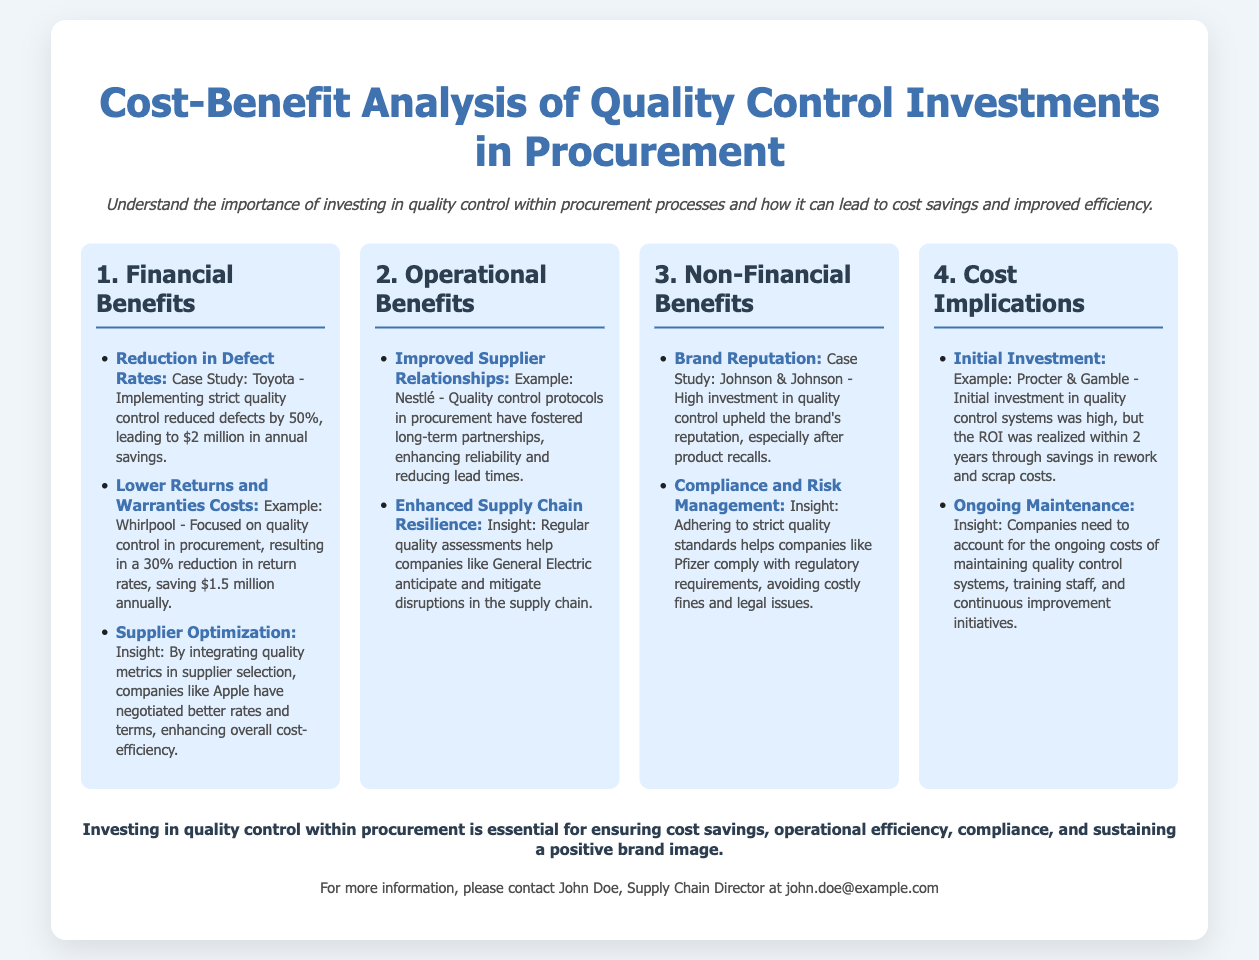what is the title of the presentation? The title of the presentation is prominently displayed at the top of the slide, which outlines the main subject matter.
Answer: Cost-Benefit Analysis of Quality Control Investments in Procurement how much did Toyota save annually after quality control implementation? The document provides a case study which mentions specific financial benefits from Toyota's quality control measures.
Answer: $2 million what percentage reduction in return rates did Whirlpool achieve? The slide discusses Whirlpool's focus on quality control and its financial implications in terms of percentage.
Answer: 30% which company improved supplier relationships through quality control? The section about operational benefits mentions a specific company that exemplified improved relationships due to quality control practices.
Answer: Nestlé what was the initial investment timeframe for Procter & Gamble's ROI? The document states a specific period related to the return on investment after initial quality control system investments.
Answer: 2 years what is a non-financial benefit of quality control mentioned? The document highlights various non-financial benefits, including those related to brand perception and compliance.
Answer: Brand Reputation which company's quality control helped avoid costly fines? An insight within the document links a specific company to compliance and risk management benefits through quality control.
Answer: Pfizer what is the color theme used in the presentation? The document's general design indicates the color choices made for the slide's background and text highlights.
Answer: Blue and white 